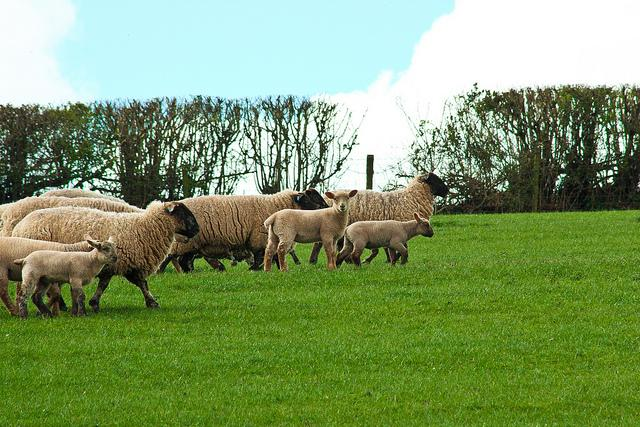Why are some of the animals smaller than other?

Choices:
A) breed
B) age
C) injuries
D) malnourished age 